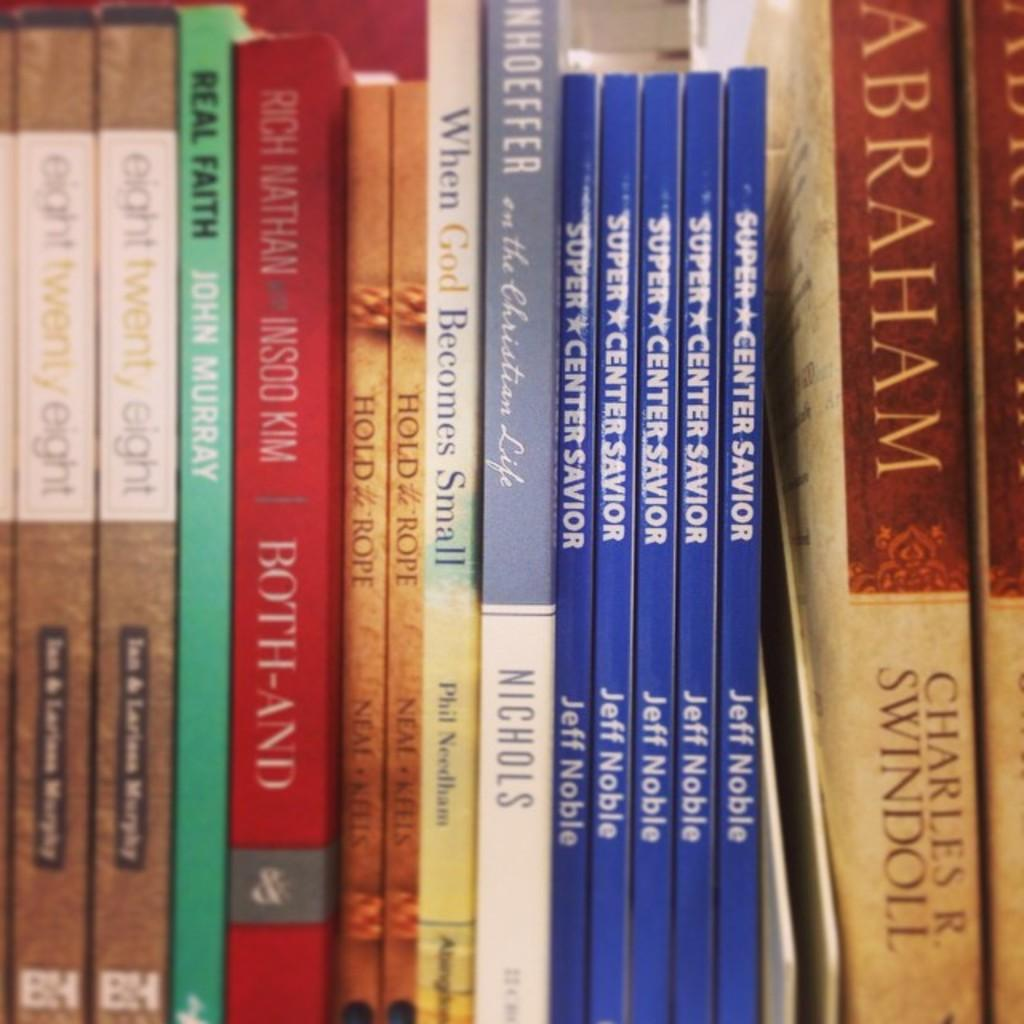<image>
Render a clear and concise summary of the photo. Volume 9 of International Security includes something written by Vojtech Mastny. 